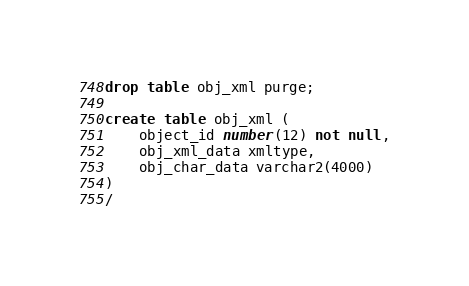Convert code to text. <code><loc_0><loc_0><loc_500><loc_500><_SQL_>

drop table obj_xml purge;

create table obj_xml (
	object_id number(12) not null,
	obj_xml_data xmltype,
	obj_char_data varchar2(4000)
)
/

</code> 